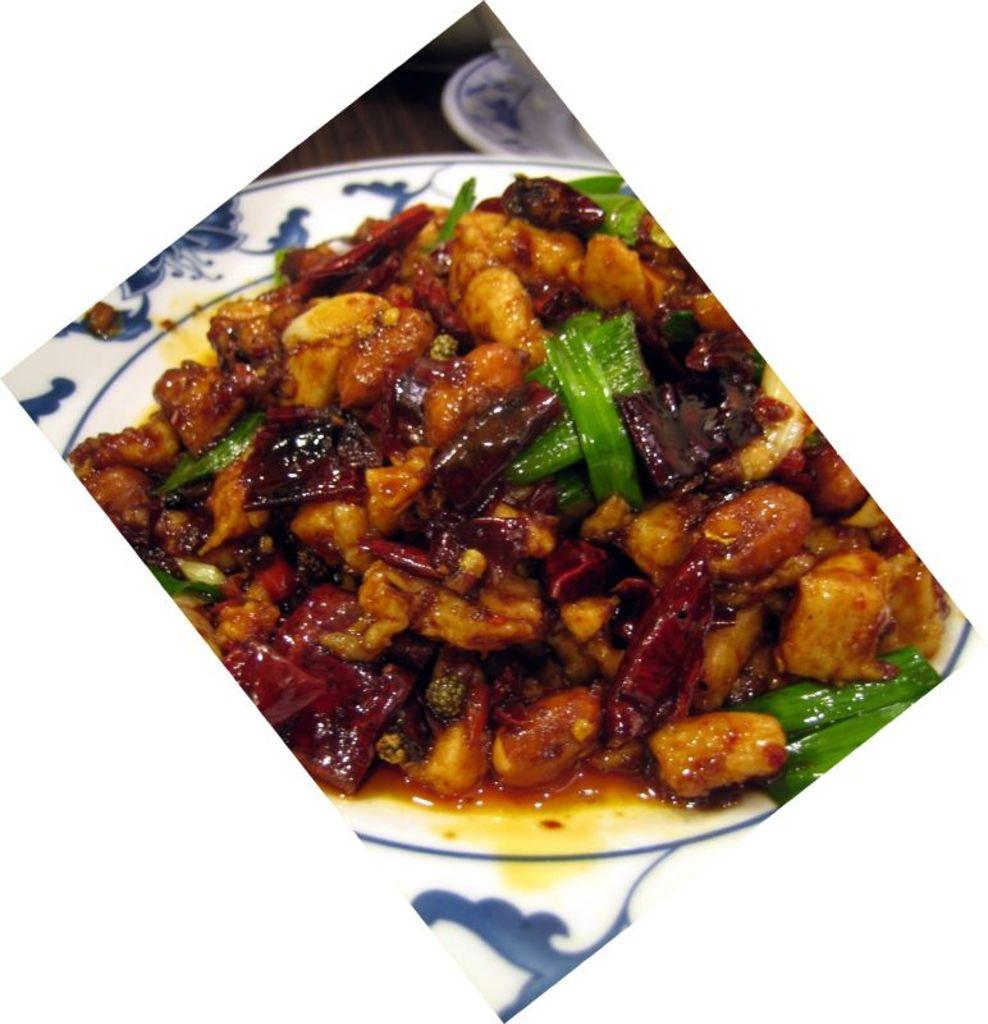What object is visible in the image that might be used for serving food? There is a plate in the image. What can be found on the plate in the image? There is food present in the plate. What type of advertisement can be seen on the plate in the image? There is no advertisement present on the plate in the image. Where is the field located in the image? There is no field present in the image. Who is the stranger interacting with the plate in the image? There is no stranger present in the image. 